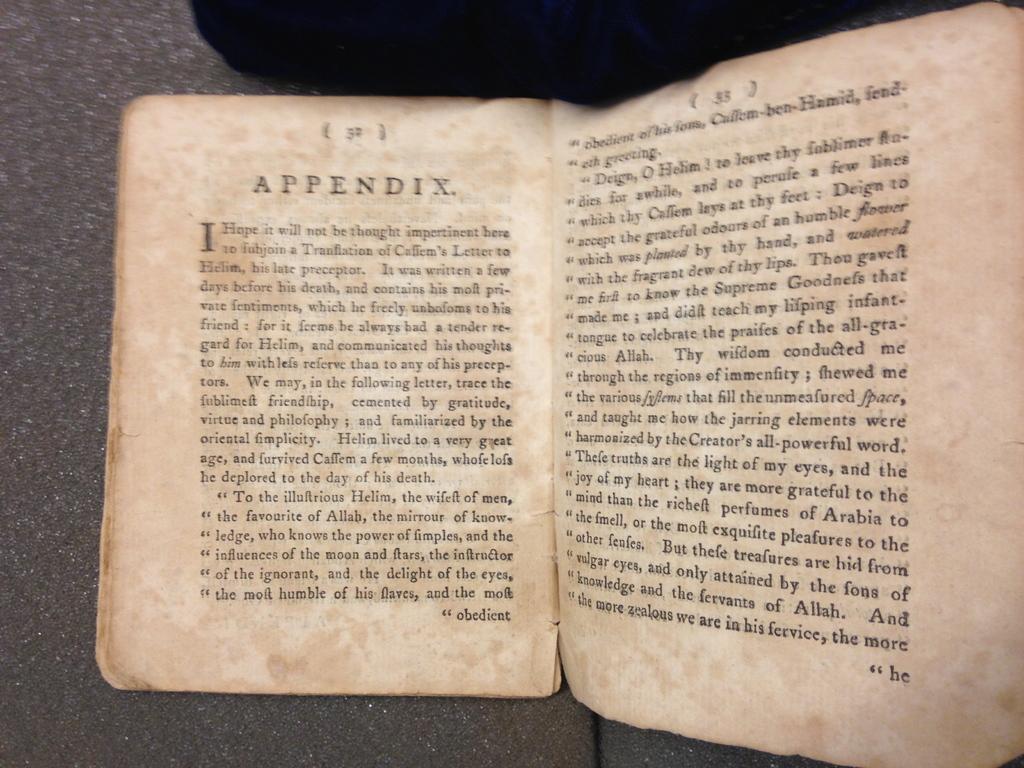What is the title of the text?
Your answer should be compact. Appendix. What is the first letter of the passage?
Make the answer very short. I. 